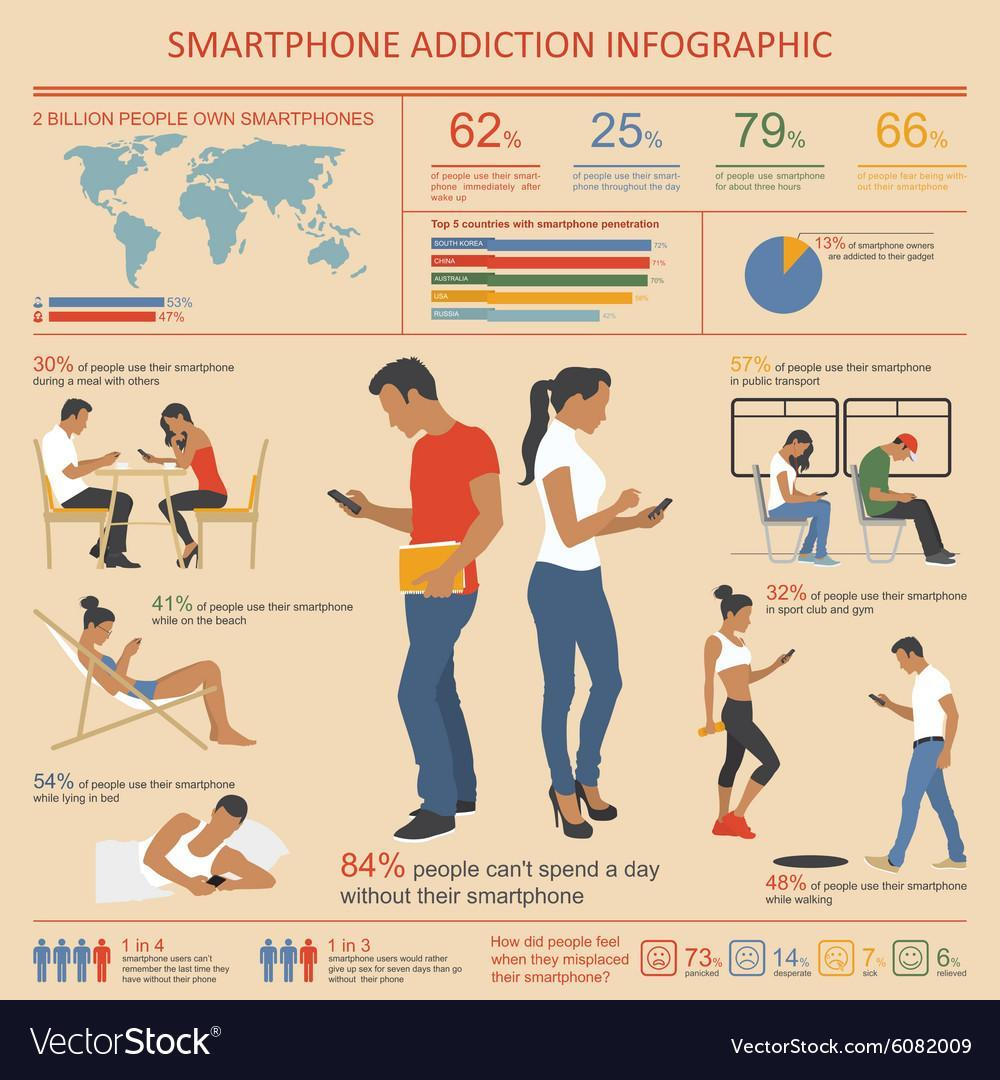What percentage of people didn't use their smartphone while lying in bed?
Answer the question with a short phrase. 46% What percentage of people are not using smartphones throughout the day? 75% What percentage of smartphone owners are not addicted to their gadgets? 87% What percentage of people didn't use their smartphone in public transport? 43% What percentage of people didn't use their smartphone during a meal with others? 70% What percentage of people are not using smartphones immediately after wake up? 38% What percentage of males own smartphones? 53% What percentage of people feel sick and panicked when they misplaced their smartphone? 80% What percentage of females own smartphones? 47% What percentage of people didn't use their smartphone in sport club and gym? 68% What percentage of people didn't use their smartphone while on the beach? 59% What percentage of people fear being without their smartphone? 66% What percentage of people use smartphones for about 3 hours? 79% What percentage of people didn't use their smartphones while walking? 52% What percentage of people can spend a day without their smartphone? 16% 